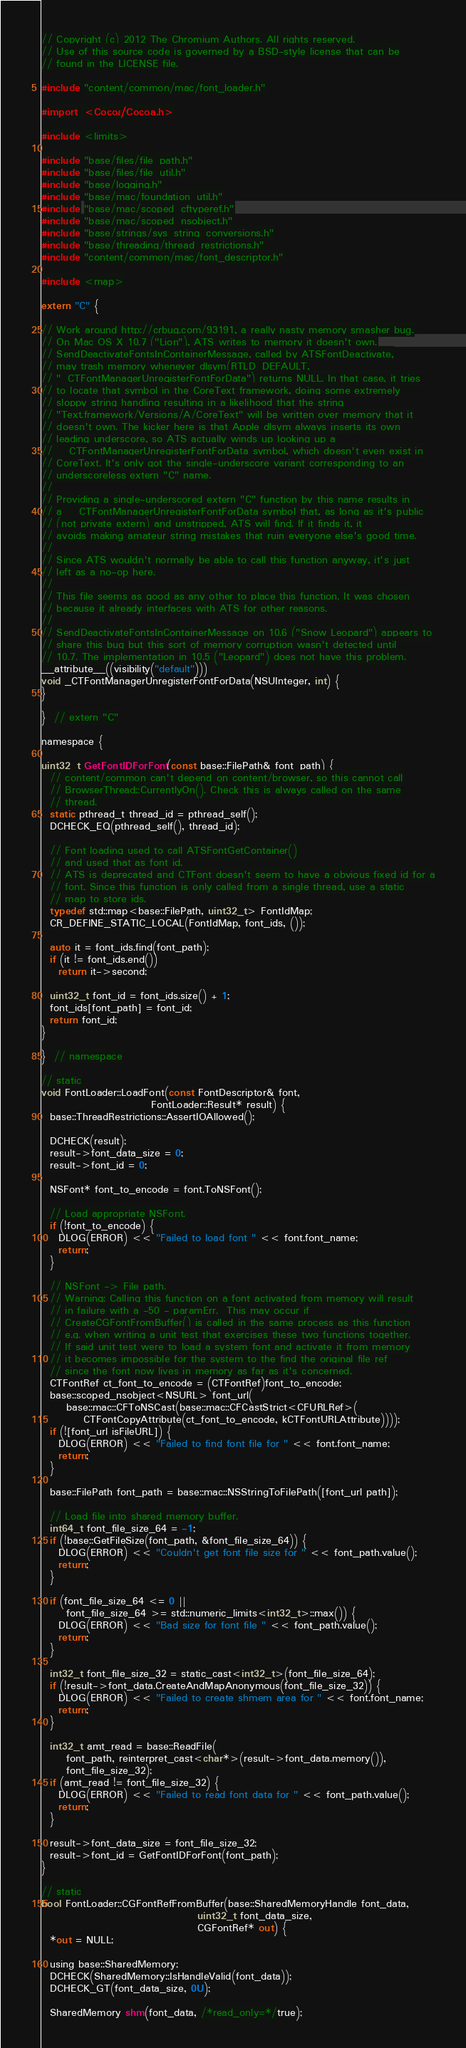<code> <loc_0><loc_0><loc_500><loc_500><_ObjectiveC_>// Copyright (c) 2012 The Chromium Authors. All rights reserved.
// Use of this source code is governed by a BSD-style license that can be
// found in the LICENSE file.

#include "content/common/mac/font_loader.h"

#import <Cocoa/Cocoa.h>

#include <limits>

#include "base/files/file_path.h"
#include "base/files/file_util.h"
#include "base/logging.h"
#include "base/mac/foundation_util.h"
#include "base/mac/scoped_cftyperef.h"
#include "base/mac/scoped_nsobject.h"
#include "base/strings/sys_string_conversions.h"
#include "base/threading/thread_restrictions.h"
#include "content/common/mac/font_descriptor.h"

#include <map>

extern "C" {

// Work around http://crbug.com/93191, a really nasty memory smasher bug.
// On Mac OS X 10.7 ("Lion"), ATS writes to memory it doesn't own.
// SendDeactivateFontsInContainerMessage, called by ATSFontDeactivate,
// may trash memory whenever dlsym(RTLD_DEFAULT,
// "_CTFontManagerUnregisterFontForData") returns NULL. In that case, it tries
// to locate that symbol in the CoreText framework, doing some extremely
// sloppy string handling resulting in a likelihood that the string
// "Text.framework/Versions/A/CoreText" will be written over memory that it
// doesn't own. The kicker here is that Apple dlsym always inserts its own
// leading underscore, so ATS actually winds up looking up a
// __CTFontManagerUnregisterFontForData symbol, which doesn't even exist in
// CoreText. It's only got the single-underscore variant corresponding to an
// underscoreless extern "C" name.
//
// Providing a single-underscored extern "C" function by this name results in
// a __CTFontManagerUnregisterFontForData symbol that, as long as it's public
// (not private extern) and unstripped, ATS will find. If it finds it, it
// avoids making amateur string mistakes that ruin everyone else's good time.
//
// Since ATS wouldn't normally be able to call this function anyway, it's just
// left as a no-op here.
//
// This file seems as good as any other to place this function. It was chosen
// because it already interfaces with ATS for other reasons.
//
// SendDeactivateFontsInContainerMessage on 10.6 ("Snow Leopard") appears to
// share this bug but this sort of memory corruption wasn't detected until
// 10.7. The implementation in 10.5 ("Leopard") does not have this problem.
__attribute__((visibility("default")))
void _CTFontManagerUnregisterFontForData(NSUInteger, int) {
}

}  // extern "C"

namespace {

uint32_t GetFontIDForFont(const base::FilePath& font_path) {
  // content/common can't depend on content/browser, so this cannot call
  // BrowserThread::CurrentlyOn(). Check this is always called on the same
  // thread.
  static pthread_t thread_id = pthread_self();
  DCHECK_EQ(pthread_self(), thread_id);

  // Font loading used to call ATSFontGetContainer()
  // and used that as font id.
  // ATS is deprecated and CTFont doesn't seem to have a obvious fixed id for a
  // font. Since this function is only called from a single thread, use a static
  // map to store ids.
  typedef std::map<base::FilePath, uint32_t> FontIdMap;
  CR_DEFINE_STATIC_LOCAL(FontIdMap, font_ids, ());

  auto it = font_ids.find(font_path);
  if (it != font_ids.end())
    return it->second;

  uint32_t font_id = font_ids.size() + 1;
  font_ids[font_path] = font_id;
  return font_id;
}

}  // namespace

// static
void FontLoader::LoadFont(const FontDescriptor& font,
                          FontLoader::Result* result) {
  base::ThreadRestrictions::AssertIOAllowed();

  DCHECK(result);
  result->font_data_size = 0;
  result->font_id = 0;

  NSFont* font_to_encode = font.ToNSFont();

  // Load appropriate NSFont.
  if (!font_to_encode) {
    DLOG(ERROR) << "Failed to load font " << font.font_name;
    return;
  }

  // NSFont -> File path.
  // Warning: Calling this function on a font activated from memory will result
  // in failure with a -50 - paramErr.  This may occur if
  // CreateCGFontFromBuffer() is called in the same process as this function
  // e.g. when writing a unit test that exercises these two functions together.
  // If said unit test were to load a system font and activate it from memory
  // it becomes impossible for the system to the find the original file ref
  // since the font now lives in memory as far as it's concerned.
  CTFontRef ct_font_to_encode = (CTFontRef)font_to_encode;
  base::scoped_nsobject<NSURL> font_url(
      base::mac::CFToNSCast(base::mac::CFCastStrict<CFURLRef>(
          CTFontCopyAttribute(ct_font_to_encode, kCTFontURLAttribute))));
  if (![font_url isFileURL]) {
    DLOG(ERROR) << "Failed to find font file for " << font.font_name;
    return;
  }

  base::FilePath font_path = base::mac::NSStringToFilePath([font_url path]);

  // Load file into shared memory buffer.
  int64_t font_file_size_64 = -1;
  if (!base::GetFileSize(font_path, &font_file_size_64)) {
    DLOG(ERROR) << "Couldn't get font file size for " << font_path.value();
    return;
  }

  if (font_file_size_64 <= 0 ||
      font_file_size_64 >= std::numeric_limits<int32_t>::max()) {
    DLOG(ERROR) << "Bad size for font file " << font_path.value();
    return;
  }

  int32_t font_file_size_32 = static_cast<int32_t>(font_file_size_64);
  if (!result->font_data.CreateAndMapAnonymous(font_file_size_32)) {
    DLOG(ERROR) << "Failed to create shmem area for " << font.font_name;
    return;
  }

  int32_t amt_read = base::ReadFile(
      font_path, reinterpret_cast<char*>(result->font_data.memory()),
      font_file_size_32);
  if (amt_read != font_file_size_32) {
    DLOG(ERROR) << "Failed to read font data for " << font_path.value();
    return;
  }

  result->font_data_size = font_file_size_32;
  result->font_id = GetFontIDForFont(font_path);
}

// static
bool FontLoader::CGFontRefFromBuffer(base::SharedMemoryHandle font_data,
                                     uint32_t font_data_size,
                                     CGFontRef* out) {
  *out = NULL;

  using base::SharedMemory;
  DCHECK(SharedMemory::IsHandleValid(font_data));
  DCHECK_GT(font_data_size, 0U);

  SharedMemory shm(font_data, /*read_only=*/true);</code> 